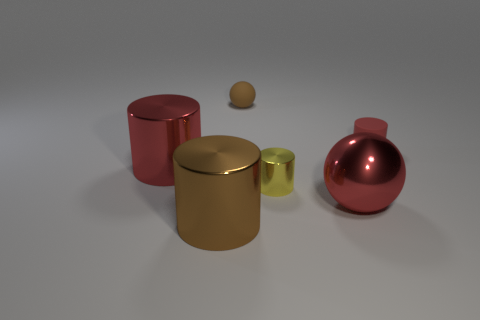How many other cylinders are the same color as the tiny rubber cylinder?
Keep it short and to the point. 1. There is a small red rubber cylinder; are there any red objects on the left side of it?
Give a very brief answer. Yes. What material is the yellow thing?
Your answer should be very brief. Metal. Is the color of the shiny object that is on the left side of the large brown metal thing the same as the small ball?
Keep it short and to the point. No. Is there any other thing that is the same shape as the small yellow metal object?
Provide a succinct answer. Yes. What is the color of the other big thing that is the same shape as the brown rubber object?
Offer a very short reply. Red. What material is the cylinder in front of the yellow object?
Make the answer very short. Metal. The metal ball is what color?
Your answer should be very brief. Red. Does the rubber object in front of the brown rubber ball have the same size as the brown cylinder?
Provide a succinct answer. No. What material is the brown object that is behind the large shiny cylinder that is in front of the red metallic cylinder that is left of the rubber ball?
Ensure brevity in your answer.  Rubber. 